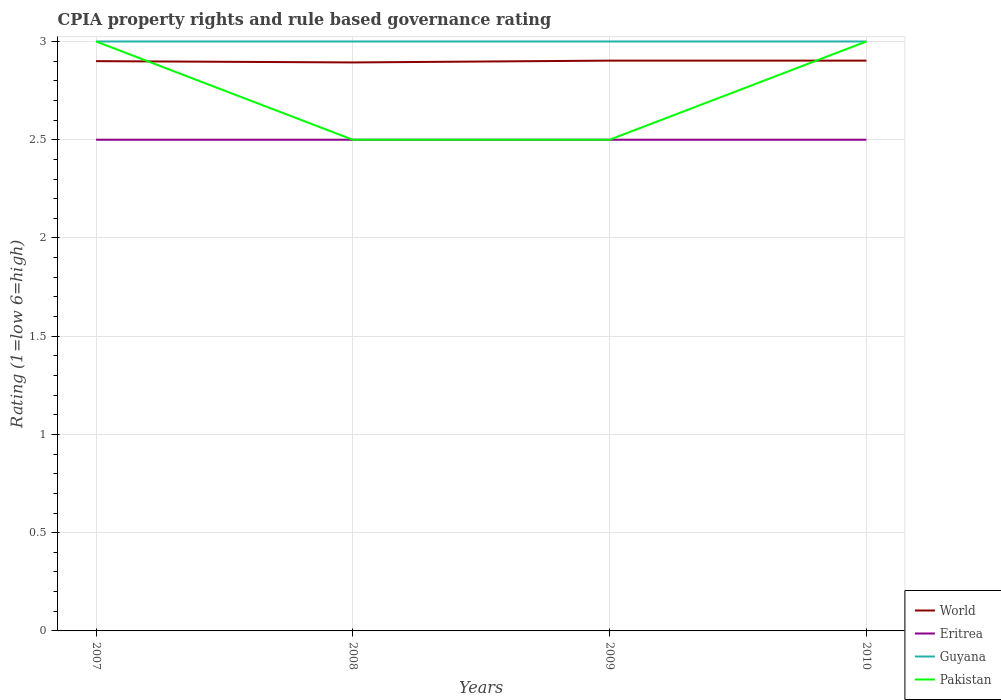Does the line corresponding to Eritrea intersect with the line corresponding to World?
Make the answer very short. No. Across all years, what is the maximum CPIA rating in Guyana?
Your response must be concise. 3. What is the total CPIA rating in World in the graph?
Make the answer very short. -0. What is the difference between the highest and the lowest CPIA rating in World?
Give a very brief answer. 3. What is the difference between two consecutive major ticks on the Y-axis?
Make the answer very short. 0.5. Does the graph contain any zero values?
Provide a short and direct response. No. Where does the legend appear in the graph?
Ensure brevity in your answer.  Bottom right. What is the title of the graph?
Provide a succinct answer. CPIA property rights and rule based governance rating. Does "Netherlands" appear as one of the legend labels in the graph?
Make the answer very short. No. What is the label or title of the X-axis?
Ensure brevity in your answer.  Years. What is the label or title of the Y-axis?
Provide a succinct answer. Rating (1=low 6=high). What is the Rating (1=low 6=high) in Eritrea in 2007?
Offer a very short reply. 2.5. What is the Rating (1=low 6=high) in Guyana in 2007?
Your answer should be compact. 3. What is the Rating (1=low 6=high) in World in 2008?
Provide a succinct answer. 2.89. What is the Rating (1=low 6=high) in Pakistan in 2008?
Make the answer very short. 2.5. What is the Rating (1=low 6=high) of World in 2009?
Offer a terse response. 2.9. What is the Rating (1=low 6=high) of Guyana in 2009?
Make the answer very short. 3. What is the Rating (1=low 6=high) of Pakistan in 2009?
Give a very brief answer. 2.5. What is the Rating (1=low 6=high) in World in 2010?
Make the answer very short. 2.9. What is the Rating (1=low 6=high) in Guyana in 2010?
Your response must be concise. 3. What is the Rating (1=low 6=high) of Pakistan in 2010?
Your response must be concise. 3. Across all years, what is the maximum Rating (1=low 6=high) of World?
Keep it short and to the point. 2.9. Across all years, what is the minimum Rating (1=low 6=high) of World?
Give a very brief answer. 2.89. Across all years, what is the minimum Rating (1=low 6=high) of Guyana?
Give a very brief answer. 3. Across all years, what is the minimum Rating (1=low 6=high) in Pakistan?
Give a very brief answer. 2.5. What is the total Rating (1=low 6=high) of World in the graph?
Offer a very short reply. 11.6. What is the total Rating (1=low 6=high) of Eritrea in the graph?
Provide a short and direct response. 10. What is the total Rating (1=low 6=high) in Guyana in the graph?
Ensure brevity in your answer.  12. What is the total Rating (1=low 6=high) in Pakistan in the graph?
Your answer should be very brief. 11. What is the difference between the Rating (1=low 6=high) of World in 2007 and that in 2008?
Keep it short and to the point. 0.01. What is the difference between the Rating (1=low 6=high) of World in 2007 and that in 2009?
Offer a very short reply. -0. What is the difference between the Rating (1=low 6=high) of Eritrea in 2007 and that in 2009?
Give a very brief answer. 0. What is the difference between the Rating (1=low 6=high) in Guyana in 2007 and that in 2009?
Your answer should be very brief. 0. What is the difference between the Rating (1=low 6=high) in World in 2007 and that in 2010?
Your answer should be compact. -0. What is the difference between the Rating (1=low 6=high) of Pakistan in 2007 and that in 2010?
Keep it short and to the point. 0. What is the difference between the Rating (1=low 6=high) of World in 2008 and that in 2009?
Offer a terse response. -0.01. What is the difference between the Rating (1=low 6=high) of Guyana in 2008 and that in 2009?
Make the answer very short. 0. What is the difference between the Rating (1=low 6=high) in Pakistan in 2008 and that in 2009?
Your response must be concise. 0. What is the difference between the Rating (1=low 6=high) in World in 2008 and that in 2010?
Provide a short and direct response. -0.01. What is the difference between the Rating (1=low 6=high) of Pakistan in 2008 and that in 2010?
Offer a very short reply. -0.5. What is the difference between the Rating (1=low 6=high) in Eritrea in 2009 and that in 2010?
Make the answer very short. 0. What is the difference between the Rating (1=low 6=high) of World in 2007 and the Rating (1=low 6=high) of Eritrea in 2008?
Your answer should be very brief. 0.4. What is the difference between the Rating (1=low 6=high) of World in 2007 and the Rating (1=low 6=high) of Guyana in 2008?
Your answer should be compact. -0.1. What is the difference between the Rating (1=low 6=high) of World in 2007 and the Rating (1=low 6=high) of Pakistan in 2008?
Provide a succinct answer. 0.4. What is the difference between the Rating (1=low 6=high) of Eritrea in 2007 and the Rating (1=low 6=high) of Pakistan in 2008?
Provide a short and direct response. 0. What is the difference between the Rating (1=low 6=high) of World in 2007 and the Rating (1=low 6=high) of Eritrea in 2009?
Make the answer very short. 0.4. What is the difference between the Rating (1=low 6=high) in World in 2007 and the Rating (1=low 6=high) in Guyana in 2009?
Keep it short and to the point. -0.1. What is the difference between the Rating (1=low 6=high) in Eritrea in 2007 and the Rating (1=low 6=high) in Pakistan in 2009?
Your answer should be very brief. 0. What is the difference between the Rating (1=low 6=high) of Guyana in 2007 and the Rating (1=low 6=high) of Pakistan in 2009?
Provide a short and direct response. 0.5. What is the difference between the Rating (1=low 6=high) in World in 2007 and the Rating (1=low 6=high) in Eritrea in 2010?
Your answer should be compact. 0.4. What is the difference between the Rating (1=low 6=high) in World in 2007 and the Rating (1=low 6=high) in Pakistan in 2010?
Your response must be concise. -0.1. What is the difference between the Rating (1=low 6=high) of Guyana in 2007 and the Rating (1=low 6=high) of Pakistan in 2010?
Offer a very short reply. 0. What is the difference between the Rating (1=low 6=high) of World in 2008 and the Rating (1=low 6=high) of Eritrea in 2009?
Your response must be concise. 0.39. What is the difference between the Rating (1=low 6=high) in World in 2008 and the Rating (1=low 6=high) in Guyana in 2009?
Your response must be concise. -0.11. What is the difference between the Rating (1=low 6=high) of World in 2008 and the Rating (1=low 6=high) of Pakistan in 2009?
Provide a short and direct response. 0.39. What is the difference between the Rating (1=low 6=high) in Eritrea in 2008 and the Rating (1=low 6=high) in Pakistan in 2009?
Offer a very short reply. 0. What is the difference between the Rating (1=low 6=high) of World in 2008 and the Rating (1=low 6=high) of Eritrea in 2010?
Keep it short and to the point. 0.39. What is the difference between the Rating (1=low 6=high) in World in 2008 and the Rating (1=low 6=high) in Guyana in 2010?
Your response must be concise. -0.11. What is the difference between the Rating (1=low 6=high) in World in 2008 and the Rating (1=low 6=high) in Pakistan in 2010?
Provide a short and direct response. -0.11. What is the difference between the Rating (1=low 6=high) of Guyana in 2008 and the Rating (1=low 6=high) of Pakistan in 2010?
Ensure brevity in your answer.  0. What is the difference between the Rating (1=low 6=high) of World in 2009 and the Rating (1=low 6=high) of Eritrea in 2010?
Offer a terse response. 0.4. What is the difference between the Rating (1=low 6=high) of World in 2009 and the Rating (1=low 6=high) of Guyana in 2010?
Your response must be concise. -0.1. What is the difference between the Rating (1=low 6=high) of World in 2009 and the Rating (1=low 6=high) of Pakistan in 2010?
Make the answer very short. -0.1. What is the difference between the Rating (1=low 6=high) of Eritrea in 2009 and the Rating (1=low 6=high) of Guyana in 2010?
Provide a succinct answer. -0.5. What is the difference between the Rating (1=low 6=high) in Guyana in 2009 and the Rating (1=low 6=high) in Pakistan in 2010?
Offer a terse response. 0. What is the average Rating (1=low 6=high) of World per year?
Give a very brief answer. 2.9. What is the average Rating (1=low 6=high) of Guyana per year?
Your response must be concise. 3. What is the average Rating (1=low 6=high) in Pakistan per year?
Your answer should be compact. 2.75. In the year 2007, what is the difference between the Rating (1=low 6=high) in World and Rating (1=low 6=high) in Pakistan?
Give a very brief answer. -0.1. In the year 2007, what is the difference between the Rating (1=low 6=high) in Eritrea and Rating (1=low 6=high) in Pakistan?
Ensure brevity in your answer.  -0.5. In the year 2007, what is the difference between the Rating (1=low 6=high) of Guyana and Rating (1=low 6=high) of Pakistan?
Provide a short and direct response. 0. In the year 2008, what is the difference between the Rating (1=low 6=high) in World and Rating (1=low 6=high) in Eritrea?
Ensure brevity in your answer.  0.39. In the year 2008, what is the difference between the Rating (1=low 6=high) in World and Rating (1=low 6=high) in Guyana?
Keep it short and to the point. -0.11. In the year 2008, what is the difference between the Rating (1=low 6=high) in World and Rating (1=low 6=high) in Pakistan?
Give a very brief answer. 0.39. In the year 2008, what is the difference between the Rating (1=low 6=high) of Eritrea and Rating (1=low 6=high) of Pakistan?
Your answer should be very brief. 0. In the year 2008, what is the difference between the Rating (1=low 6=high) of Guyana and Rating (1=low 6=high) of Pakistan?
Your answer should be very brief. 0.5. In the year 2009, what is the difference between the Rating (1=low 6=high) in World and Rating (1=low 6=high) in Eritrea?
Your answer should be very brief. 0.4. In the year 2009, what is the difference between the Rating (1=low 6=high) in World and Rating (1=low 6=high) in Guyana?
Offer a very short reply. -0.1. In the year 2009, what is the difference between the Rating (1=low 6=high) of World and Rating (1=low 6=high) of Pakistan?
Your response must be concise. 0.4. In the year 2009, what is the difference between the Rating (1=low 6=high) in Eritrea and Rating (1=low 6=high) in Guyana?
Provide a short and direct response. -0.5. In the year 2010, what is the difference between the Rating (1=low 6=high) of World and Rating (1=low 6=high) of Eritrea?
Offer a very short reply. 0.4. In the year 2010, what is the difference between the Rating (1=low 6=high) in World and Rating (1=low 6=high) in Guyana?
Offer a very short reply. -0.1. In the year 2010, what is the difference between the Rating (1=low 6=high) of World and Rating (1=low 6=high) of Pakistan?
Ensure brevity in your answer.  -0.1. In the year 2010, what is the difference between the Rating (1=low 6=high) in Eritrea and Rating (1=low 6=high) in Pakistan?
Give a very brief answer. -0.5. In the year 2010, what is the difference between the Rating (1=low 6=high) of Guyana and Rating (1=low 6=high) of Pakistan?
Make the answer very short. 0. What is the ratio of the Rating (1=low 6=high) of Guyana in 2007 to that in 2008?
Offer a very short reply. 1. What is the ratio of the Rating (1=low 6=high) of Guyana in 2007 to that in 2009?
Offer a terse response. 1. What is the ratio of the Rating (1=low 6=high) in Pakistan in 2007 to that in 2009?
Your response must be concise. 1.2. What is the ratio of the Rating (1=low 6=high) of World in 2007 to that in 2010?
Ensure brevity in your answer.  1. What is the ratio of the Rating (1=low 6=high) of Eritrea in 2007 to that in 2010?
Offer a very short reply. 1. What is the ratio of the Rating (1=low 6=high) of Guyana in 2007 to that in 2010?
Your response must be concise. 1. What is the ratio of the Rating (1=low 6=high) in Pakistan in 2007 to that in 2010?
Provide a succinct answer. 1. What is the ratio of the Rating (1=low 6=high) of World in 2008 to that in 2009?
Ensure brevity in your answer.  1. What is the ratio of the Rating (1=low 6=high) in Pakistan in 2008 to that in 2009?
Your answer should be very brief. 1. What is the ratio of the Rating (1=low 6=high) in Pakistan in 2008 to that in 2010?
Keep it short and to the point. 0.83. What is the ratio of the Rating (1=low 6=high) in Guyana in 2009 to that in 2010?
Make the answer very short. 1. What is the difference between the highest and the second highest Rating (1=low 6=high) in World?
Keep it short and to the point. 0. What is the difference between the highest and the lowest Rating (1=low 6=high) in World?
Give a very brief answer. 0.01. What is the difference between the highest and the lowest Rating (1=low 6=high) of Guyana?
Your response must be concise. 0. What is the difference between the highest and the lowest Rating (1=low 6=high) in Pakistan?
Your answer should be compact. 0.5. 